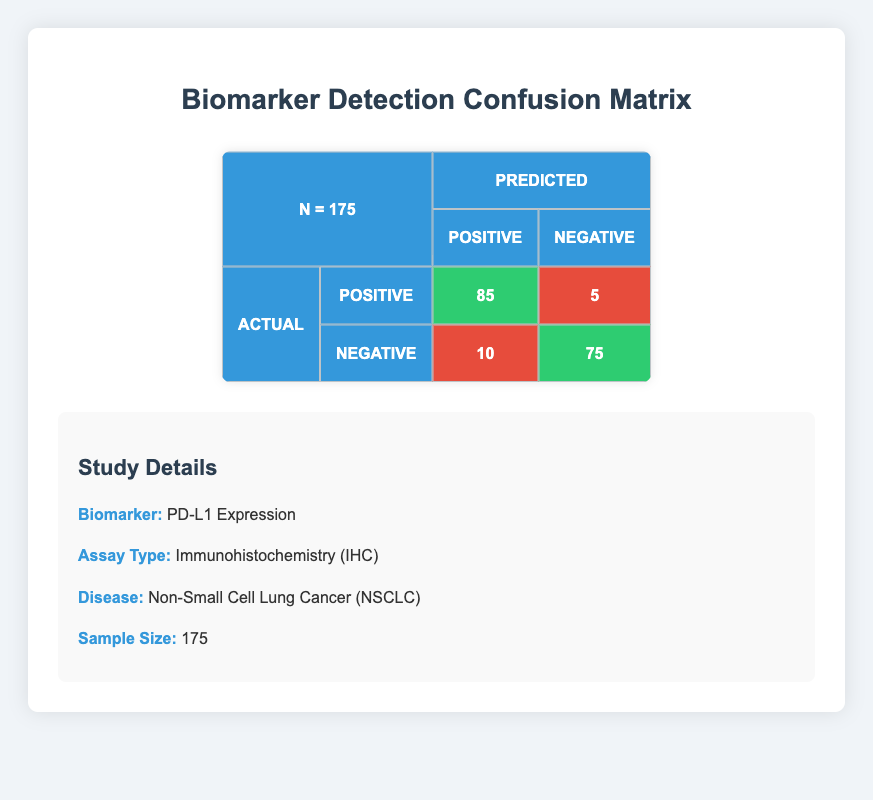What is the total number of true positive cases in this study? The table indicates that there are 85 true positive cases, which are cases where the biomarker was correctly identified as positive.
Answer: 85 How many false negative cases are there? The table shows that there are 5 false negative cases, where the biomarker was actually positive but incorrectly identified as negative.
Answer: 5 What is the total number of participants who were correctly identified as negative? The table provides that there are 75 true negative cases plus 10 false positives. Correctly identified negative cases are only the true negatives, so the total is 75.
Answer: 75 What is the specificity of the biomarker detection? Specificity is calculated as the number of true negatives (75) divided by the sum of true negatives and false positives (75 + 10 = 85). Therefore, specificity is 75 / 85 = 0.882, or approximately 88.2%.
Answer: 88.2% Is the number of true positives greater than false negatives? The table indicates that there are 85 true positives and 5 false negatives. Since 85 is greater than 5, this statement is true.
Answer: Yes How many total positive predictions were made? The total positive predictions include both true positives and false positives. The table shows 85 true positives and 10 false positives. Therefore, the total positive predictions are 85 + 10 = 95.
Answer: 95 What is the proportion of false positives to total positive predictions? The number of false positives is 10, and the total number of positive predictions is 95. The proportion is 10 / 95, which simplifies to approximately 0.105, or about 10.5%.
Answer: 10.5% What is the total number of subjects with actual positive results? The total number of subjects with actual positive results consists of true positives and false negatives. The sum is 85 true positives plus 5 false negatives, which is 90.
Answer: 90 What is the overall accuracy of the biomarker detection? Overall accuracy is calculated as the sum of true positives and true negatives divided by the total number of subjects. The sum of true positives (85) and true negatives (75) is 160, and the total sample size is 175. Thus, accuracy is 160 / 175 = 0.914, or approximately 91.4%.
Answer: 91.4% 